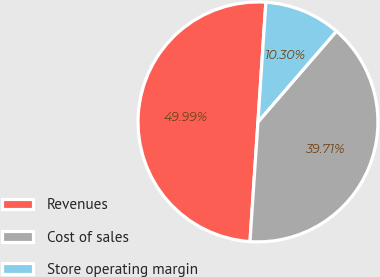Convert chart to OTSL. <chart><loc_0><loc_0><loc_500><loc_500><pie_chart><fcel>Revenues<fcel>Cost of sales<fcel>Store operating margin<nl><fcel>49.99%<fcel>39.71%<fcel>10.3%<nl></chart> 